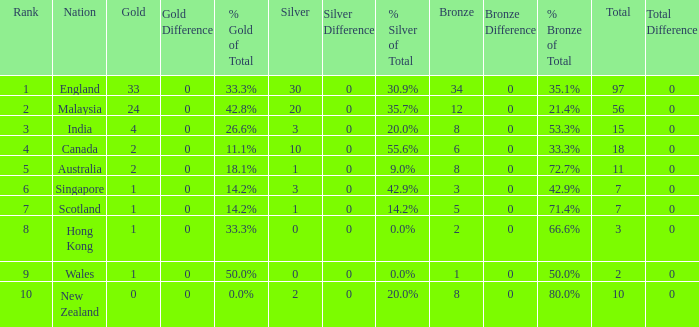What is the most gold medals a team with less than 2 silvers, more than 7 total medals, and less than 8 bronze medals has? None. 